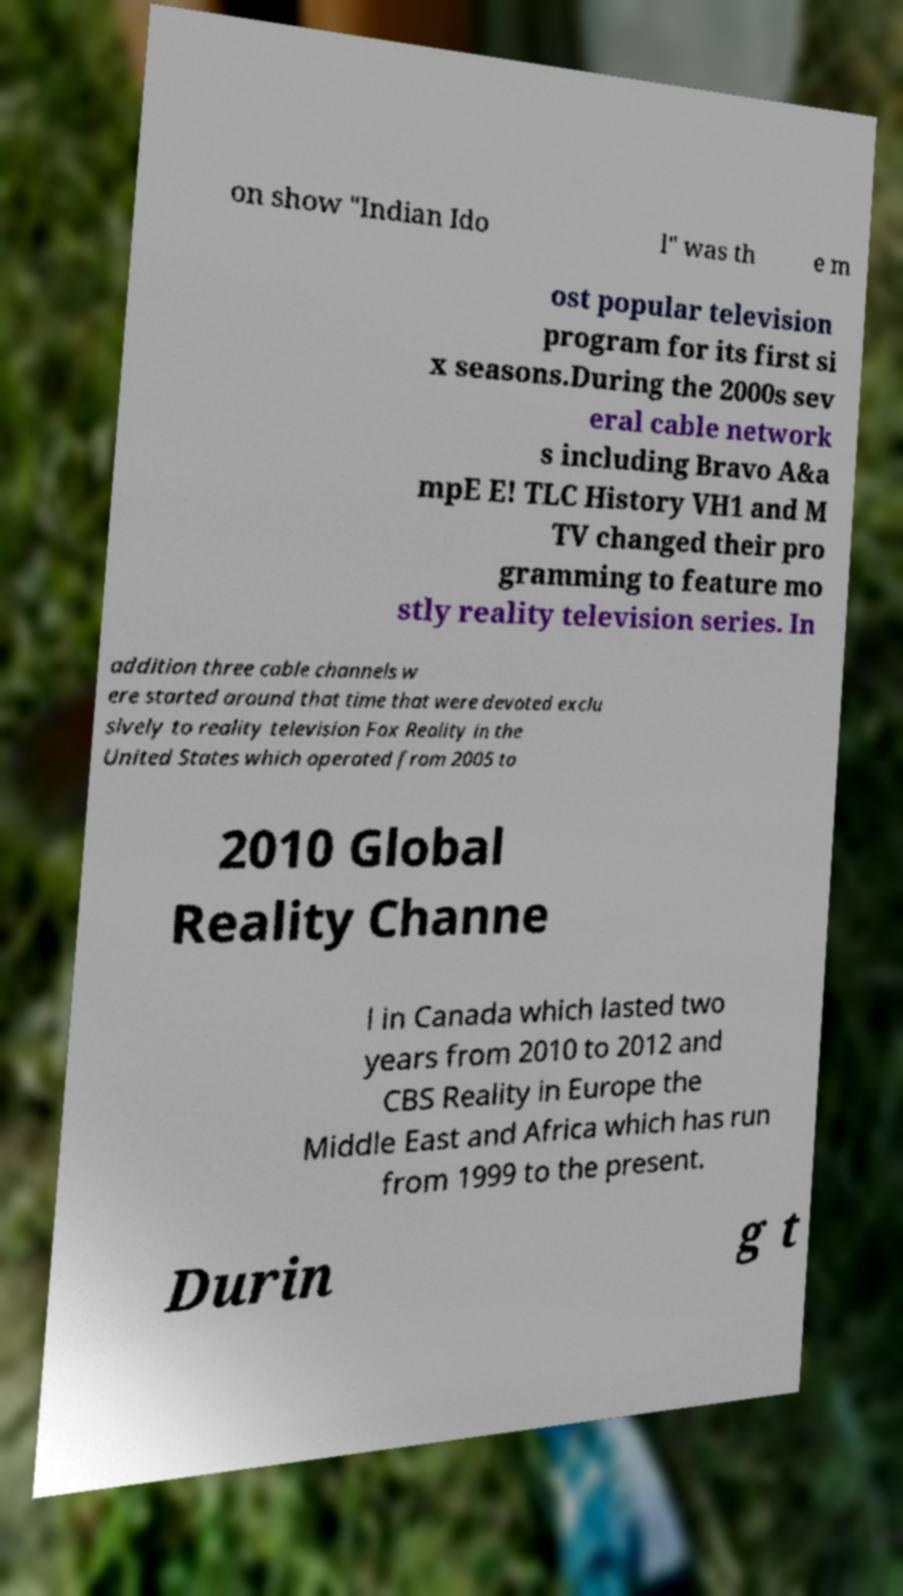What messages or text are displayed in this image? I need them in a readable, typed format. on show "Indian Ido l" was th e m ost popular television program for its first si x seasons.During the 2000s sev eral cable network s including Bravo A&a mpE E! TLC History VH1 and M TV changed their pro gramming to feature mo stly reality television series. In addition three cable channels w ere started around that time that were devoted exclu sively to reality television Fox Reality in the United States which operated from 2005 to 2010 Global Reality Channe l in Canada which lasted two years from 2010 to 2012 and CBS Reality in Europe the Middle East and Africa which has run from 1999 to the present. Durin g t 